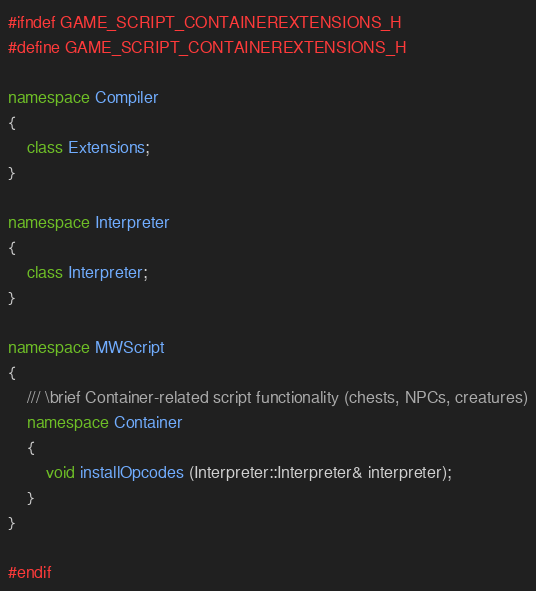Convert code to text. <code><loc_0><loc_0><loc_500><loc_500><_C++_>#ifndef GAME_SCRIPT_CONTAINEREXTENSIONS_H
#define GAME_SCRIPT_CONTAINEREXTENSIONS_H

namespace Compiler
{
    class Extensions;
}

namespace Interpreter
{
    class Interpreter;
}

namespace MWScript
{
    /// \brief Container-related script functionality (chests, NPCs, creatures)
    namespace Container
    {
        void installOpcodes (Interpreter::Interpreter& interpreter);
    }
}

#endif
</code> 